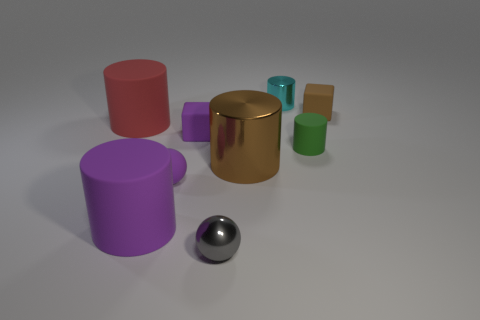What size is the matte block that is the same color as the small matte sphere?
Provide a succinct answer. Small. What is the material of the purple object that is the same size as the red thing?
Give a very brief answer. Rubber. Is the size of the cylinder that is behind the small brown object the same as the rubber cylinder to the right of the gray ball?
Your answer should be compact. Yes. Are there any purple spheres that have the same material as the tiny green object?
Provide a short and direct response. Yes. What number of objects are big things to the right of the gray sphere or brown metallic cylinders?
Make the answer very short. 1. Are the tiny ball that is in front of the tiny matte sphere and the small brown cube made of the same material?
Ensure brevity in your answer.  No. Do the small cyan thing and the large purple rubber thing have the same shape?
Your answer should be very brief. Yes. What number of small purple cubes are in front of the tiny metallic object in front of the large purple rubber object?
Make the answer very short. 0. There is a big red object that is the same shape as the large brown metallic object; what is it made of?
Make the answer very short. Rubber. There is a cylinder behind the brown rubber block; is its color the same as the small metallic ball?
Make the answer very short. No. 